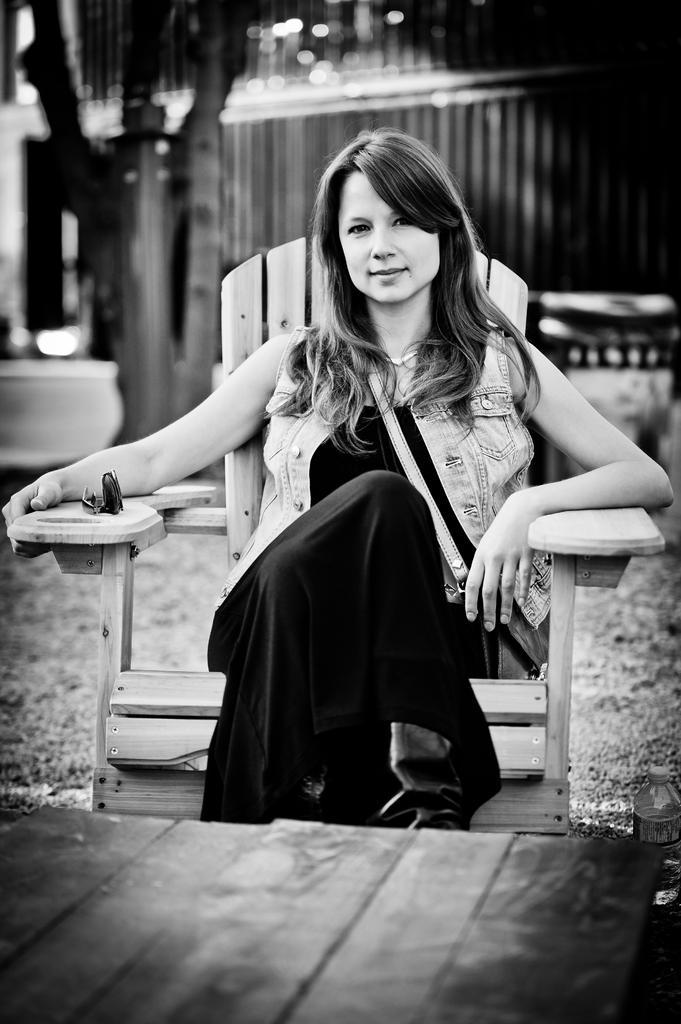In one or two sentences, can you explain what this image depicts? This is a black and white image, in this image there is a woman sitting in a chair, in front of the woman there is a wooden platform, behind the woman there are trees and some objects and a wall. 